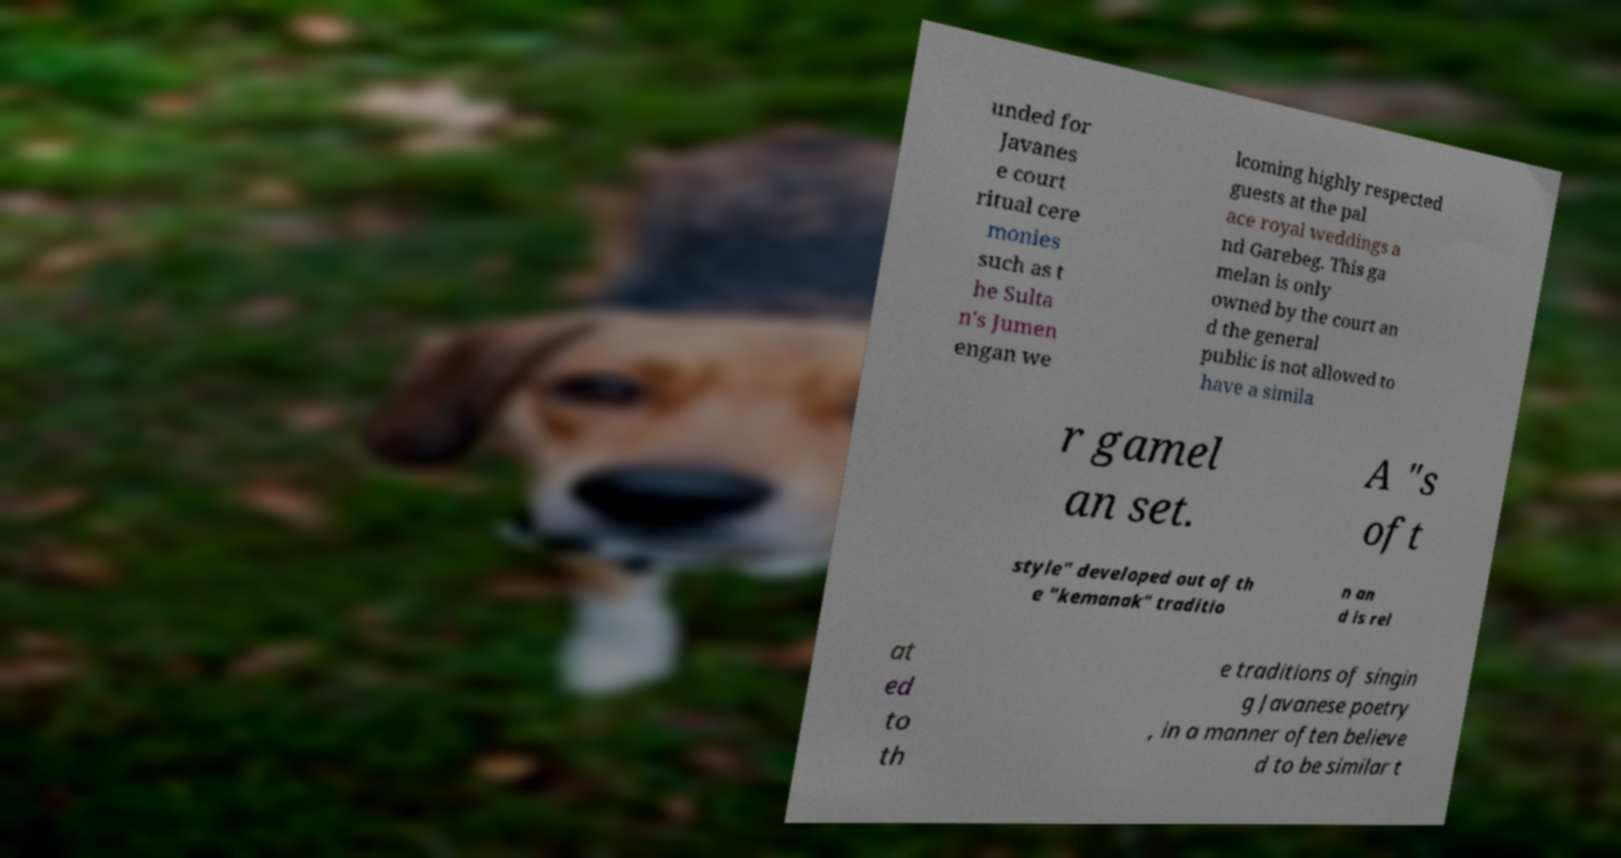Please identify and transcribe the text found in this image. unded for Javanes e court ritual cere monies such as t he Sulta n's Jumen engan we lcoming highly respected guests at the pal ace royal weddings a nd Garebeg. This ga melan is only owned by the court an d the general public is not allowed to have a simila r gamel an set. A "s oft style" developed out of th e "kemanak" traditio n an d is rel at ed to th e traditions of singin g Javanese poetry , in a manner often believe d to be similar t 